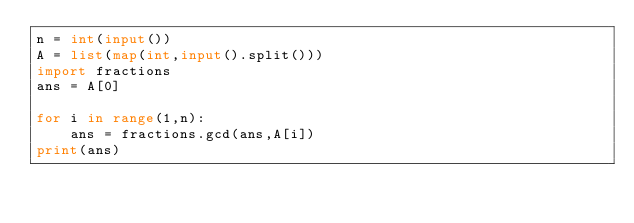<code> <loc_0><loc_0><loc_500><loc_500><_Python_>n = int(input())
A = list(map(int,input().split()))
import fractions
ans = A[0]

for i in range(1,n):
    ans = fractions.gcd(ans,A[i])
print(ans)
</code> 